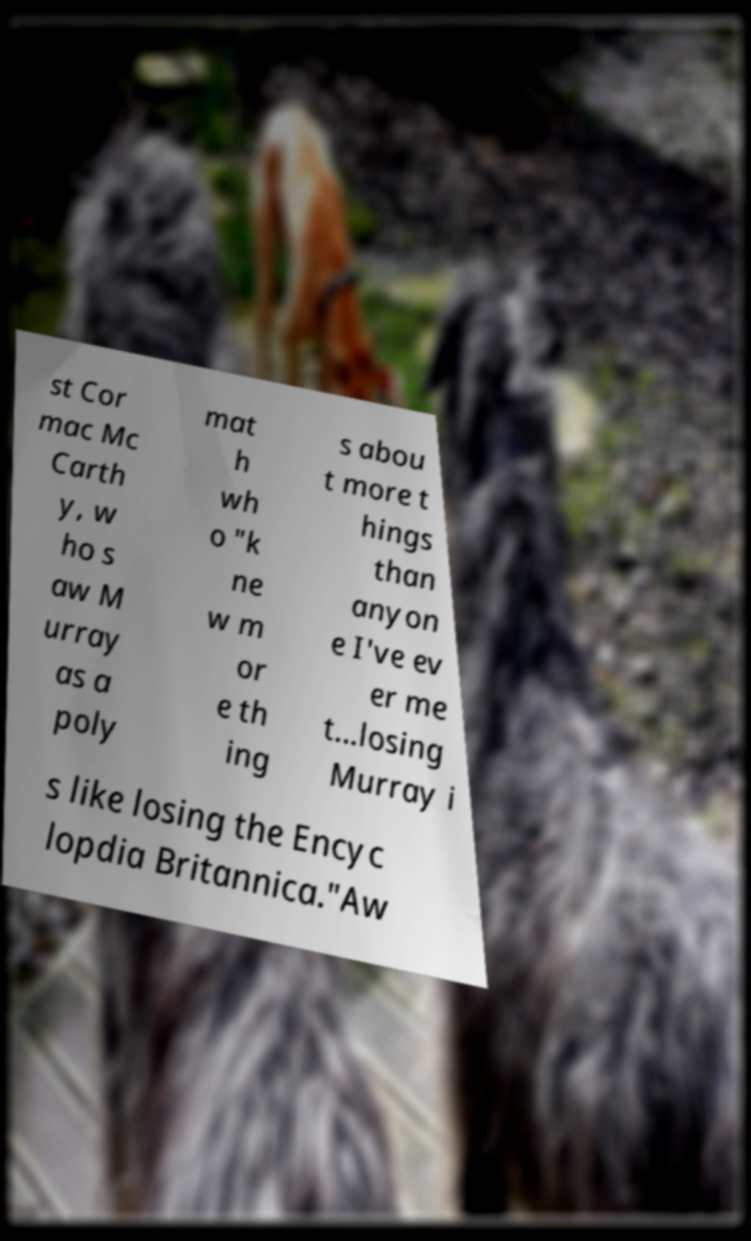Please read and relay the text visible in this image. What does it say? st Cor mac Mc Carth y, w ho s aw M urray as a poly mat h wh o "k ne w m or e th ing s abou t more t hings than anyon e I've ev er me t...losing Murray i s like losing the Encyc lopdia Britannica."Aw 